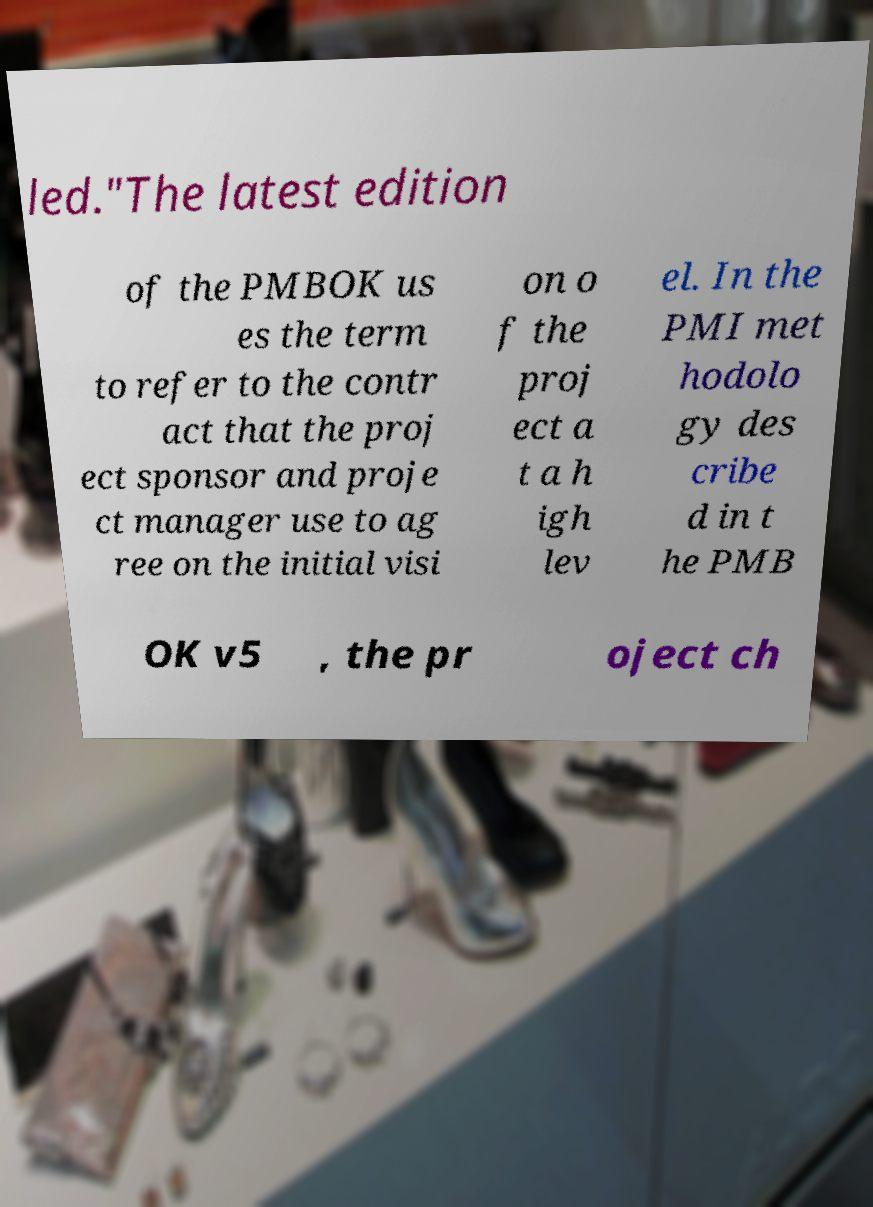Please identify and transcribe the text found in this image. led."The latest edition of the PMBOK us es the term to refer to the contr act that the proj ect sponsor and proje ct manager use to ag ree on the initial visi on o f the proj ect a t a h igh lev el. In the PMI met hodolo gy des cribe d in t he PMB OK v5 , the pr oject ch 